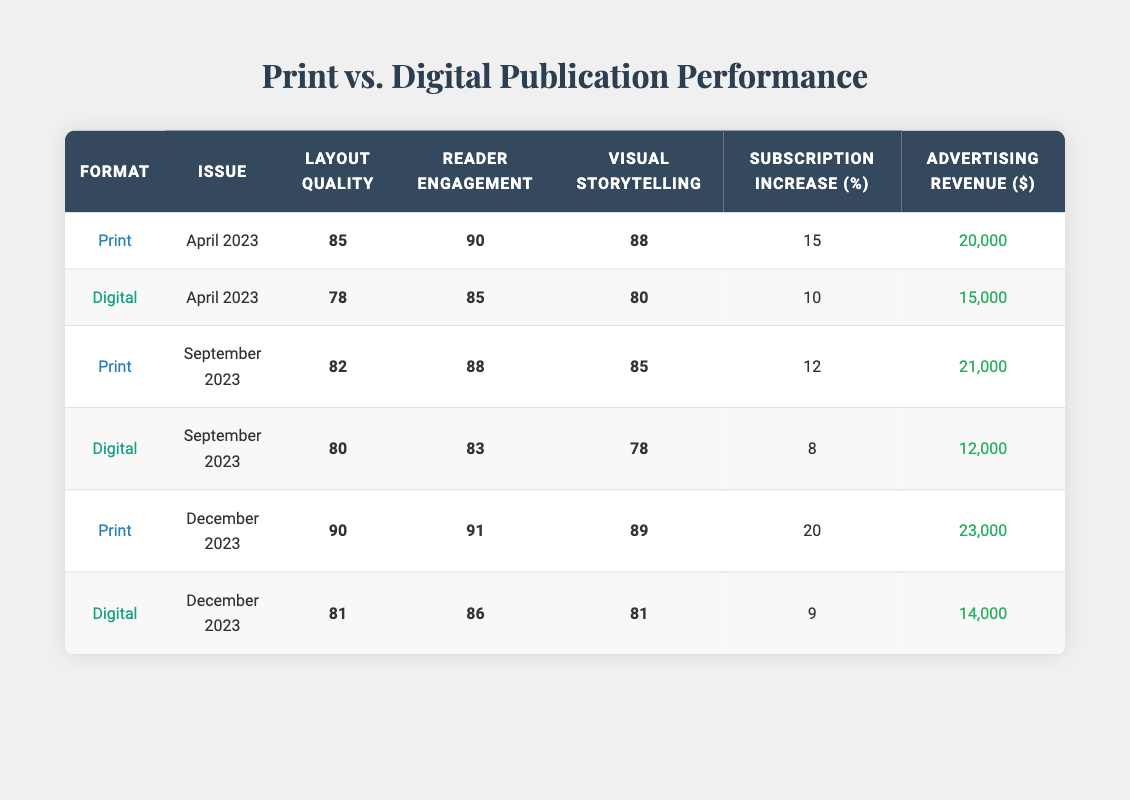What is the visual storytelling score for the April 2023 Print issue? The table shows that for the April 2023 Print issue, the visual storytelling score is 88.
Answer: 88 Which format had a higher reader engagement score in September 2023? In September 2023, the Print format had a reader engagement score of 88, while the Digital format had a score of 83. Therefore, the Print format had a higher score.
Answer: Print What is the difference in advertising revenue between the Print and Digital formats for December 2023? The Print format generated 23,000 in advertising revenue, whereas the Digital format generated 14,000. The difference is calculated as 23,000 - 14,000, which equals 9,000.
Answer: 9,000 Did the Digital format have a subscription increase rate greater than 10% in any of the issues listed? Looking at the subscription increase values for Digital format across all issues; April has 10%, September has 8%, and December has 9%. None of these values exceed 10%, so the answer is no.
Answer: No What is the average layout quality score for the Print format across all issues? The layout quality scores for Print format in the table are 85, 82, and 90. To find the average, we sum these scores: 85 + 82 + 90 = 257, and divide by the number of issues, which is 3. The average is 257 / 3 = approximately 85.67.
Answer: 85.67 How many more subscription increases did the Print format achieve compared to Digital format in April 2023? In April 2023, Print had a subscription increase of 15%, and Digital had 10%. The difference between these values is 15 - 10 = 5%. This means Print achieved 5% more subscription increase than Digital.
Answer: 5% Is the visual storytelling score for the December 2023 Digital format greater than that of the September 2023 Print format? The December 2023 Digital format has a visual storytelling score of 81, while the September 2023 Print format has a score of 85. Since 81 is less than 85, the answer is no.
Answer: No Which issue had the highest overall revenue, and what was the format? Checking the advertising revenue for each format: Print in December 2023 had 23,000, which is higher than any other format listed. Therefore, the issue with the highest revenue is December 2023, and the format is Print.
Answer: December 2023 Print What is the median reader engagement score across all issues for the Digital format? The reader engagement scores for the Digital format are 85 (April), 83 (September), and 86 (December). Arranging these scores: 83, 85, 86. The median, which is the middle value, is 85.
Answer: 85 